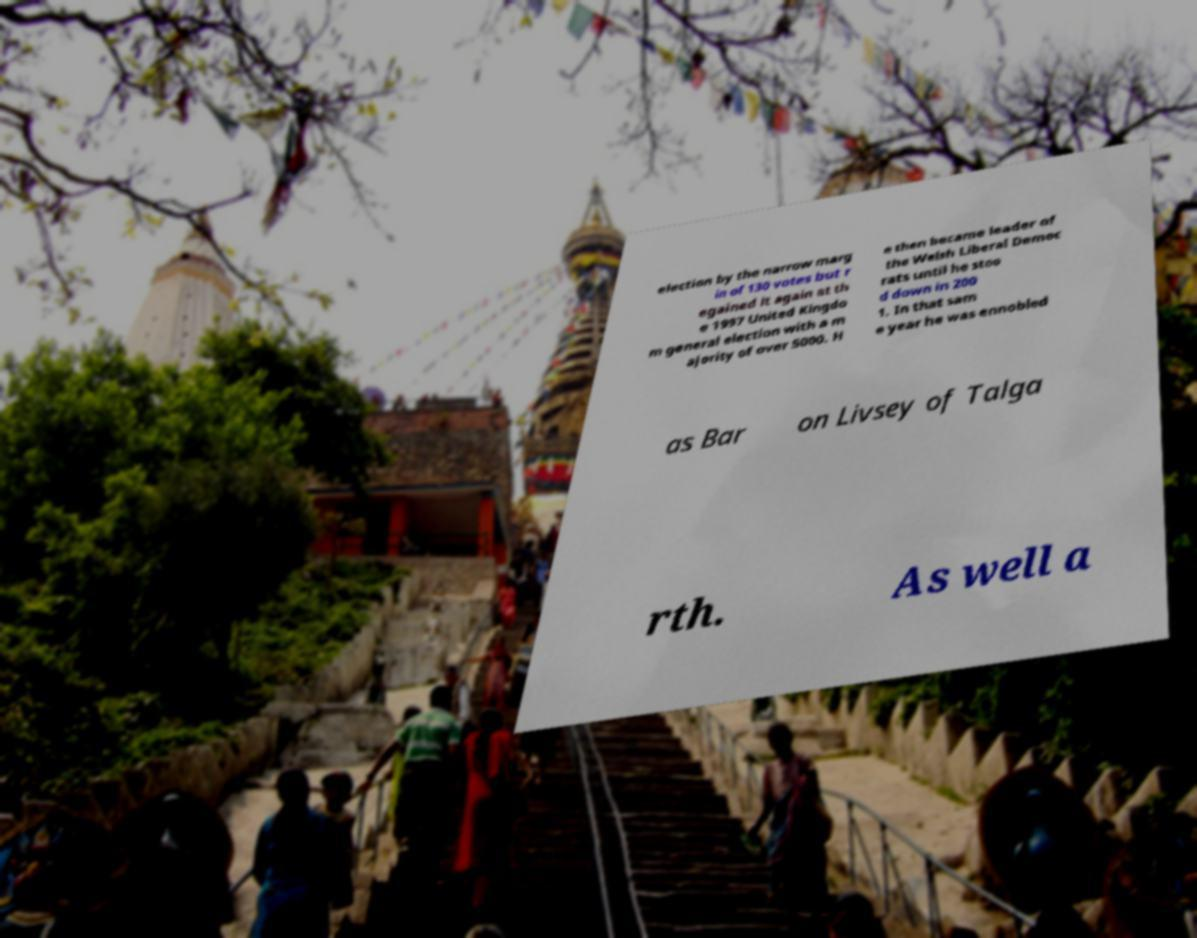Please identify and transcribe the text found in this image. election by the narrow marg in of 130 votes but r egained it again at th e 1997 United Kingdo m general election with a m ajority of over 5000. H e then became leader of the Welsh Liberal Democ rats until he stoo d down in 200 1. In that sam e year he was ennobled as Bar on Livsey of Talga rth. As well a 